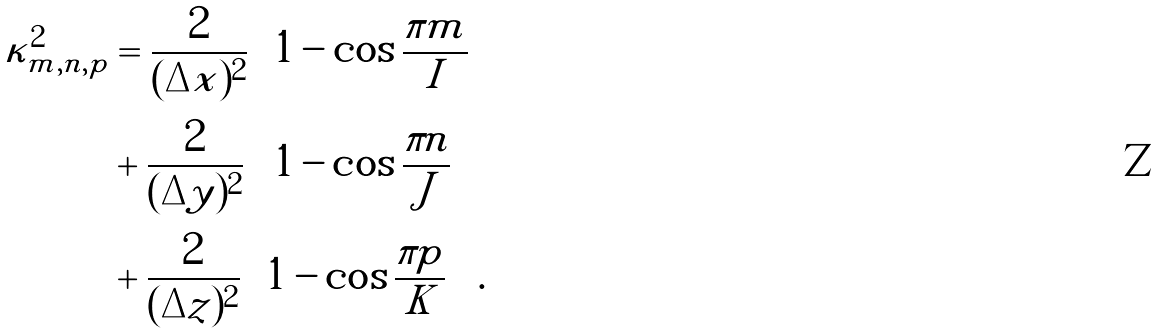<formula> <loc_0><loc_0><loc_500><loc_500>\kappa ^ { 2 } _ { m , n , p } & = \frac { 2 } { ( \Delta x ) ^ { 2 } } \left ( 1 - \cos \frac { \pi m } { I } \right ) \\ & + \frac { 2 } { ( \Delta y ) ^ { 2 } } \left ( 1 - \cos \frac { \pi n } { J } \right ) \\ & + \frac { 2 } { ( \Delta z ) ^ { 2 } } \left ( 1 - \cos \frac { \pi p } { K } \right ) \, .</formula> 